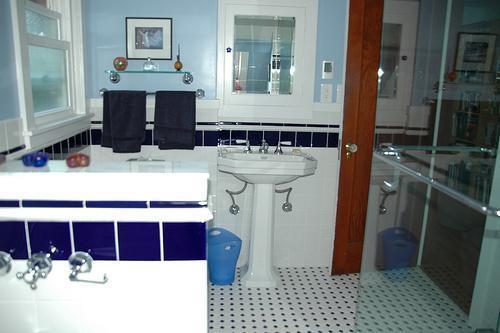How many mirrors are there?
Give a very brief answer. 1. 